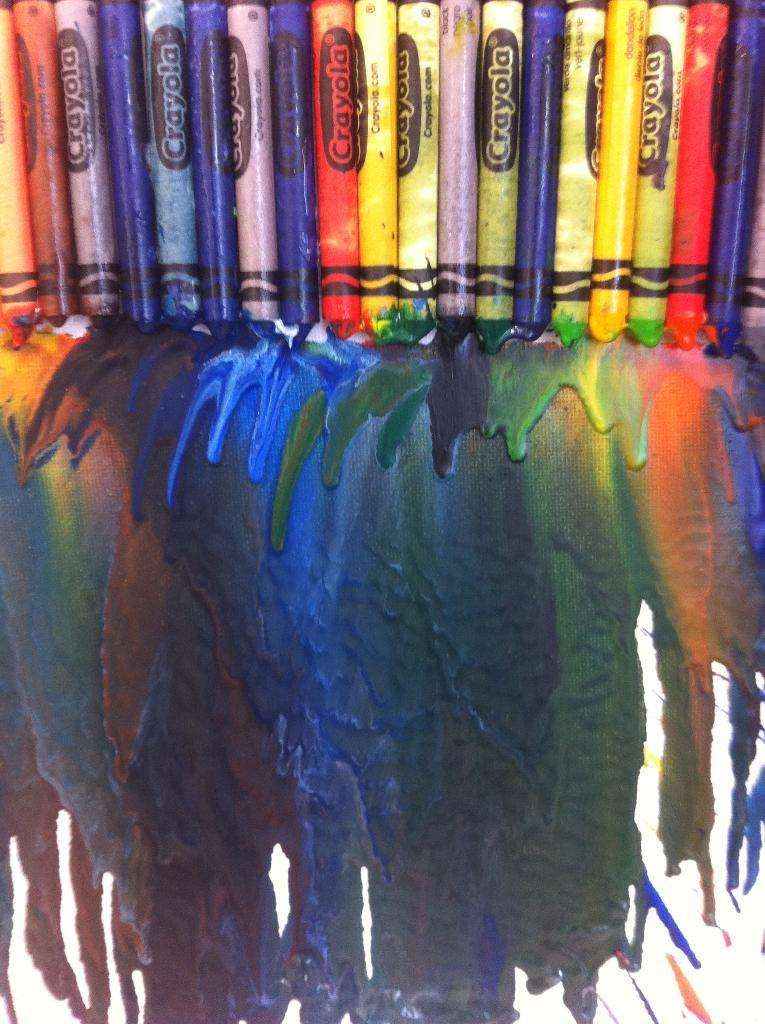What objects are present in the image? There are crayons in the image. What can be seen on the paper in the image? There are different colors on the paper. What type of tramp is visible in the image? There is no tramp present in the image; it features crayons and colored paper. What is the purpose of the crate in the image? There is no crate present in the image. 